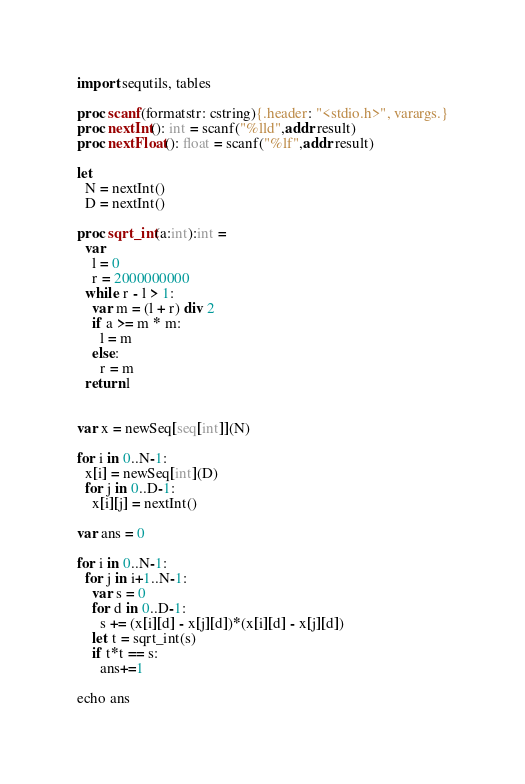Convert code to text. <code><loc_0><loc_0><loc_500><loc_500><_Nim_>import sequtils, tables

proc scanf(formatstr: cstring){.header: "<stdio.h>", varargs.}
proc nextInt(): int = scanf("%lld",addr result)
proc nextFloat(): float = scanf("%lf",addr result)

let
  N = nextInt()
  D = nextInt()

proc sqrt_int(a:int):int =
  var
    l = 0
    r = 2000000000
  while r - l > 1:
    var m = (l + r) div 2
    if a >= m * m:
      l = m
    else:
      r = m
  return l


var x = newSeq[seq[int]](N)

for i in 0..N-1:
  x[i] = newSeq[int](D)
  for j in 0..D-1:
    x[i][j] = nextInt()

var ans = 0

for i in 0..N-1:
  for j in i+1..N-1:
    var s = 0
    for d in 0..D-1:
      s += (x[i][d] - x[j][d])*(x[i][d] - x[j][d])
    let t = sqrt_int(s)
    if t*t == s:
      ans+=1

echo ans</code> 